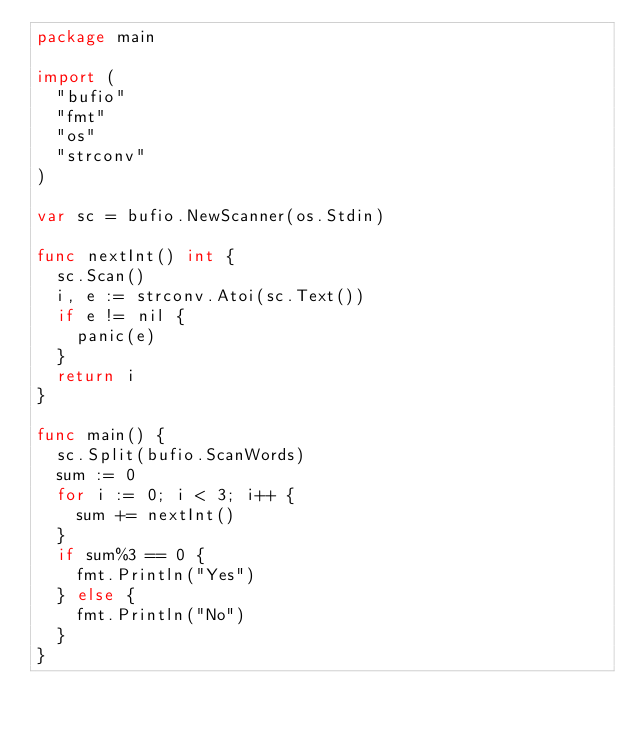<code> <loc_0><loc_0><loc_500><loc_500><_Go_>package main

import (
	"bufio"
	"fmt"
	"os"
	"strconv"
)

var sc = bufio.NewScanner(os.Stdin)

func nextInt() int {
	sc.Scan()
	i, e := strconv.Atoi(sc.Text())
	if e != nil {
		panic(e)
	}
	return i
}

func main() {
	sc.Split(bufio.ScanWords)
	sum := 0
	for i := 0; i < 3; i++ {
		sum += nextInt()
	}
	if sum%3 == 0 {
		fmt.Println("Yes")
	} else {
		fmt.Println("No")
	}
}
</code> 